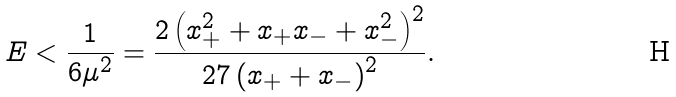Convert formula to latex. <formula><loc_0><loc_0><loc_500><loc_500>E < \frac { 1 } { 6 \mu ^ { 2 } } = \frac { 2 \left ( x _ { + } ^ { 2 } + x _ { + } x _ { - } + x _ { - } ^ { 2 } \right ) ^ { 2 } } { 2 7 \left ( x _ { + } + x _ { - } \right ) ^ { 2 } } .</formula> 